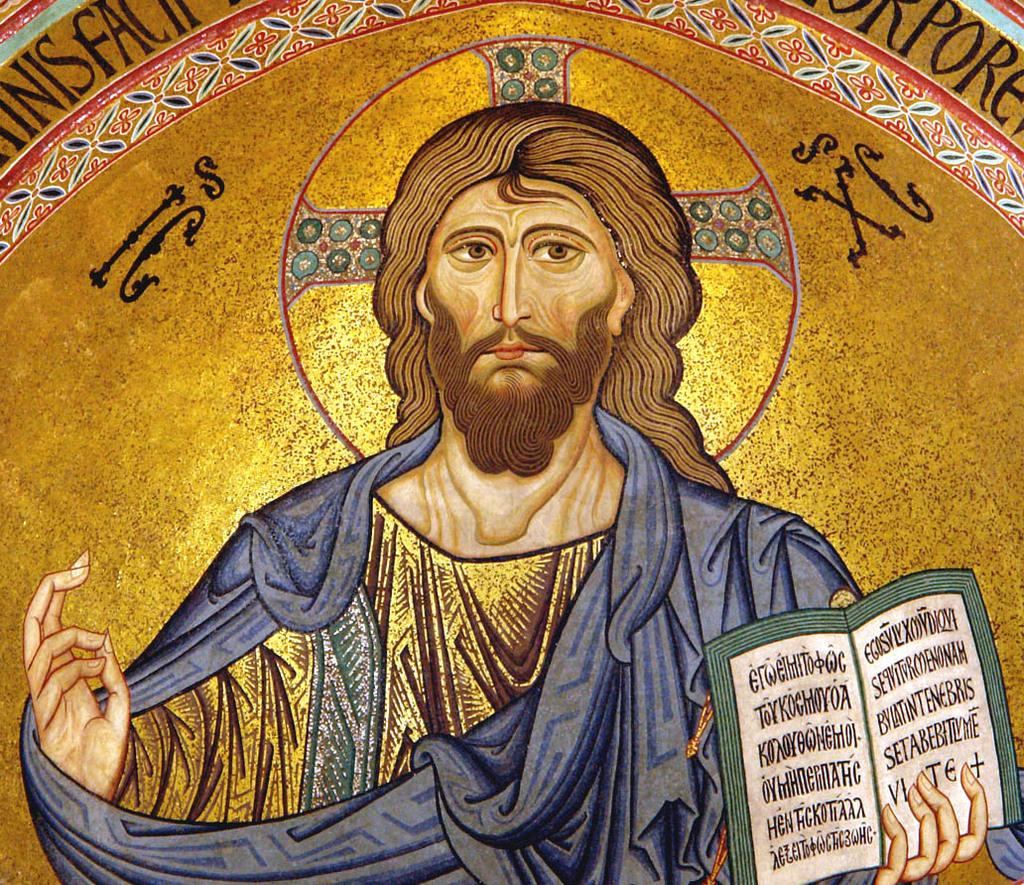What is the main subject of the image? There is an art piece in the image. What is depicted in the art piece? The art piece contains Jesus. What is Jesus holding in the art piece? Jesus is holding a bible with his hand. What type of ornament is hanging from Jesus's arm in the image? There is no ornament hanging from Jesus's arm in the image. Is Jesus wearing a watch in the image? There is no watch visible on Jesus in the image. 